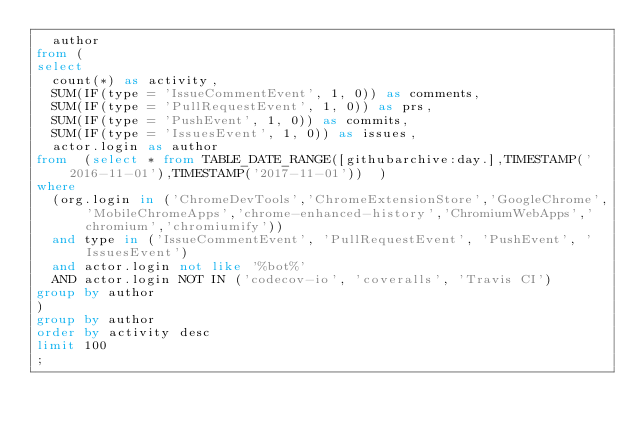<code> <loc_0><loc_0><loc_500><loc_500><_SQL_>  author
from (
select
  count(*) as activity,
  SUM(IF(type = 'IssueCommentEvent', 1, 0)) as comments,
  SUM(IF(type = 'PullRequestEvent', 1, 0)) as prs,
  SUM(IF(type = 'PushEvent', 1, 0)) as commits,
  SUM(IF(type = 'IssuesEvent', 1, 0)) as issues,
  actor.login as author
from  (select * from TABLE_DATE_RANGE([githubarchive:day.],TIMESTAMP('2016-11-01'),TIMESTAMP('2017-11-01'))  )
where
  (org.login in ('ChromeDevTools','ChromeExtensionStore','GoogleChrome','MobileChromeApps','chrome-enhanced-history','ChromiumWebApps','chromium','chromiumify'))
  and type in ('IssueCommentEvent', 'PullRequestEvent', 'PushEvent', 'IssuesEvent')
  and actor.login not like '%bot%'  
  AND actor.login NOT IN ('codecov-io', 'coveralls', 'Travis CI')
group by author
)
group by author
order by activity desc
limit 100
;
</code> 